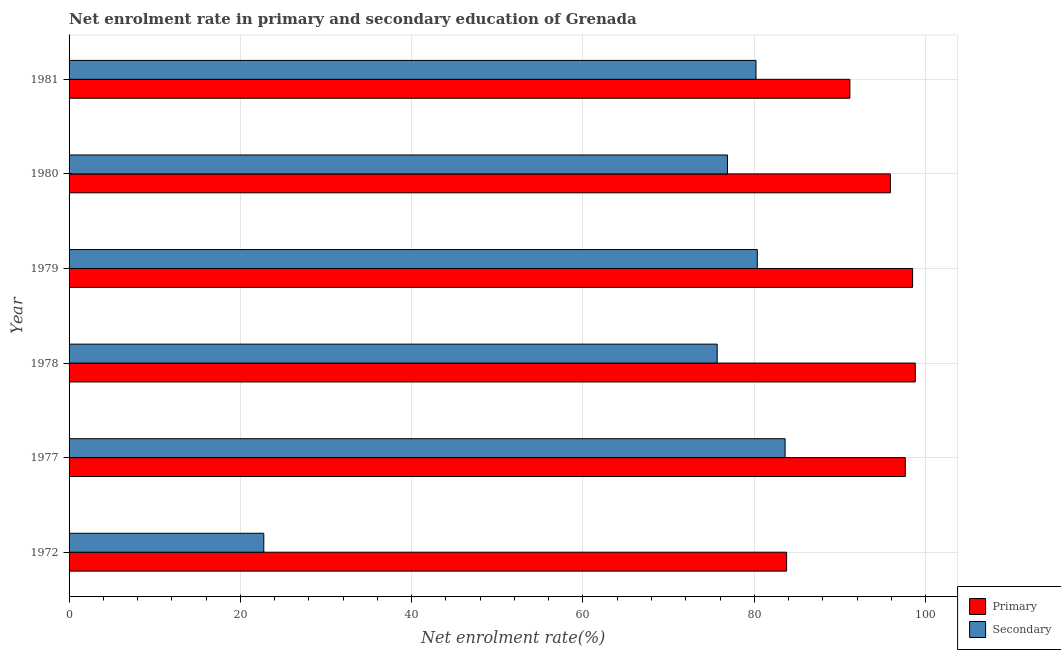How many different coloured bars are there?
Your answer should be compact. 2. Are the number of bars on each tick of the Y-axis equal?
Your answer should be compact. Yes. How many bars are there on the 2nd tick from the top?
Give a very brief answer. 2. What is the label of the 1st group of bars from the top?
Offer a terse response. 1981. What is the enrollment rate in primary education in 1981?
Offer a terse response. 91.16. Across all years, what is the maximum enrollment rate in primary education?
Keep it short and to the point. 98.8. Across all years, what is the minimum enrollment rate in primary education?
Your answer should be very brief. 83.77. In which year was the enrollment rate in primary education maximum?
Give a very brief answer. 1978. In which year was the enrollment rate in primary education minimum?
Your response must be concise. 1972. What is the total enrollment rate in primary education in the graph?
Make the answer very short. 565.73. What is the difference between the enrollment rate in primary education in 1978 and that in 1980?
Provide a succinct answer. 2.91. What is the difference between the enrollment rate in secondary education in 1981 and the enrollment rate in primary education in 1977?
Your answer should be compact. -17.43. What is the average enrollment rate in secondary education per year?
Ensure brevity in your answer.  69.9. In the year 1972, what is the difference between the enrollment rate in primary education and enrollment rate in secondary education?
Your answer should be compact. 61.04. What is the ratio of the enrollment rate in secondary education in 1977 to that in 1980?
Provide a short and direct response. 1.09. What is the difference between the highest and the second highest enrollment rate in secondary education?
Provide a succinct answer. 3.25. What is the difference between the highest and the lowest enrollment rate in secondary education?
Ensure brevity in your answer.  60.86. What does the 1st bar from the top in 1981 represents?
Give a very brief answer. Secondary. What does the 2nd bar from the bottom in 1979 represents?
Give a very brief answer. Secondary. How many bars are there?
Your answer should be compact. 12. What is the difference between two consecutive major ticks on the X-axis?
Your answer should be compact. 20. Are the values on the major ticks of X-axis written in scientific E-notation?
Give a very brief answer. No. How are the legend labels stacked?
Your answer should be compact. Vertical. What is the title of the graph?
Give a very brief answer. Net enrolment rate in primary and secondary education of Grenada. What is the label or title of the X-axis?
Make the answer very short. Net enrolment rate(%). What is the Net enrolment rate(%) of Primary in 1972?
Keep it short and to the point. 83.77. What is the Net enrolment rate(%) of Secondary in 1972?
Offer a terse response. 22.74. What is the Net enrolment rate(%) of Primary in 1977?
Provide a short and direct response. 97.63. What is the Net enrolment rate(%) of Secondary in 1977?
Provide a short and direct response. 83.6. What is the Net enrolment rate(%) of Primary in 1978?
Give a very brief answer. 98.8. What is the Net enrolment rate(%) in Secondary in 1978?
Provide a succinct answer. 75.67. What is the Net enrolment rate(%) in Primary in 1979?
Make the answer very short. 98.49. What is the Net enrolment rate(%) of Secondary in 1979?
Your answer should be very brief. 80.35. What is the Net enrolment rate(%) of Primary in 1980?
Offer a very short reply. 95.89. What is the Net enrolment rate(%) in Secondary in 1980?
Offer a very short reply. 76.87. What is the Net enrolment rate(%) of Primary in 1981?
Offer a very short reply. 91.16. What is the Net enrolment rate(%) in Secondary in 1981?
Ensure brevity in your answer.  80.2. Across all years, what is the maximum Net enrolment rate(%) in Primary?
Give a very brief answer. 98.8. Across all years, what is the maximum Net enrolment rate(%) of Secondary?
Offer a very short reply. 83.6. Across all years, what is the minimum Net enrolment rate(%) of Primary?
Offer a very short reply. 83.77. Across all years, what is the minimum Net enrolment rate(%) of Secondary?
Your answer should be very brief. 22.74. What is the total Net enrolment rate(%) in Primary in the graph?
Provide a short and direct response. 565.73. What is the total Net enrolment rate(%) of Secondary in the graph?
Offer a very short reply. 419.43. What is the difference between the Net enrolment rate(%) of Primary in 1972 and that in 1977?
Ensure brevity in your answer.  -13.86. What is the difference between the Net enrolment rate(%) in Secondary in 1972 and that in 1977?
Provide a short and direct response. -60.86. What is the difference between the Net enrolment rate(%) of Primary in 1972 and that in 1978?
Your response must be concise. -15.02. What is the difference between the Net enrolment rate(%) of Secondary in 1972 and that in 1978?
Provide a short and direct response. -52.93. What is the difference between the Net enrolment rate(%) in Primary in 1972 and that in 1979?
Make the answer very short. -14.71. What is the difference between the Net enrolment rate(%) in Secondary in 1972 and that in 1979?
Your answer should be very brief. -57.62. What is the difference between the Net enrolment rate(%) in Primary in 1972 and that in 1980?
Ensure brevity in your answer.  -12.11. What is the difference between the Net enrolment rate(%) of Secondary in 1972 and that in 1980?
Your answer should be compact. -54.14. What is the difference between the Net enrolment rate(%) in Primary in 1972 and that in 1981?
Your answer should be very brief. -7.39. What is the difference between the Net enrolment rate(%) in Secondary in 1972 and that in 1981?
Keep it short and to the point. -57.46. What is the difference between the Net enrolment rate(%) in Primary in 1977 and that in 1978?
Ensure brevity in your answer.  -1.17. What is the difference between the Net enrolment rate(%) of Secondary in 1977 and that in 1978?
Keep it short and to the point. 7.93. What is the difference between the Net enrolment rate(%) in Primary in 1977 and that in 1979?
Your response must be concise. -0.86. What is the difference between the Net enrolment rate(%) of Secondary in 1977 and that in 1979?
Your answer should be compact. 3.25. What is the difference between the Net enrolment rate(%) of Primary in 1977 and that in 1980?
Your response must be concise. 1.74. What is the difference between the Net enrolment rate(%) in Secondary in 1977 and that in 1980?
Give a very brief answer. 6.73. What is the difference between the Net enrolment rate(%) of Primary in 1977 and that in 1981?
Offer a terse response. 6.47. What is the difference between the Net enrolment rate(%) in Secondary in 1977 and that in 1981?
Ensure brevity in your answer.  3.4. What is the difference between the Net enrolment rate(%) of Primary in 1978 and that in 1979?
Offer a very short reply. 0.31. What is the difference between the Net enrolment rate(%) in Secondary in 1978 and that in 1979?
Give a very brief answer. -4.68. What is the difference between the Net enrolment rate(%) of Primary in 1978 and that in 1980?
Make the answer very short. 2.91. What is the difference between the Net enrolment rate(%) of Secondary in 1978 and that in 1980?
Keep it short and to the point. -1.2. What is the difference between the Net enrolment rate(%) in Primary in 1978 and that in 1981?
Ensure brevity in your answer.  7.64. What is the difference between the Net enrolment rate(%) of Secondary in 1978 and that in 1981?
Give a very brief answer. -4.53. What is the difference between the Net enrolment rate(%) of Primary in 1979 and that in 1980?
Keep it short and to the point. 2.6. What is the difference between the Net enrolment rate(%) in Secondary in 1979 and that in 1980?
Offer a terse response. 3.48. What is the difference between the Net enrolment rate(%) in Primary in 1979 and that in 1981?
Ensure brevity in your answer.  7.33. What is the difference between the Net enrolment rate(%) in Secondary in 1979 and that in 1981?
Your answer should be compact. 0.15. What is the difference between the Net enrolment rate(%) in Primary in 1980 and that in 1981?
Offer a very short reply. 4.73. What is the difference between the Net enrolment rate(%) in Secondary in 1980 and that in 1981?
Make the answer very short. -3.33. What is the difference between the Net enrolment rate(%) in Primary in 1972 and the Net enrolment rate(%) in Secondary in 1977?
Keep it short and to the point. 0.18. What is the difference between the Net enrolment rate(%) of Primary in 1972 and the Net enrolment rate(%) of Secondary in 1978?
Keep it short and to the point. 8.1. What is the difference between the Net enrolment rate(%) of Primary in 1972 and the Net enrolment rate(%) of Secondary in 1979?
Keep it short and to the point. 3.42. What is the difference between the Net enrolment rate(%) of Primary in 1972 and the Net enrolment rate(%) of Secondary in 1980?
Ensure brevity in your answer.  6.9. What is the difference between the Net enrolment rate(%) in Primary in 1972 and the Net enrolment rate(%) in Secondary in 1981?
Offer a very short reply. 3.57. What is the difference between the Net enrolment rate(%) in Primary in 1977 and the Net enrolment rate(%) in Secondary in 1978?
Your answer should be very brief. 21.96. What is the difference between the Net enrolment rate(%) in Primary in 1977 and the Net enrolment rate(%) in Secondary in 1979?
Ensure brevity in your answer.  17.28. What is the difference between the Net enrolment rate(%) of Primary in 1977 and the Net enrolment rate(%) of Secondary in 1980?
Provide a succinct answer. 20.76. What is the difference between the Net enrolment rate(%) of Primary in 1977 and the Net enrolment rate(%) of Secondary in 1981?
Your response must be concise. 17.43. What is the difference between the Net enrolment rate(%) in Primary in 1978 and the Net enrolment rate(%) in Secondary in 1979?
Give a very brief answer. 18.45. What is the difference between the Net enrolment rate(%) of Primary in 1978 and the Net enrolment rate(%) of Secondary in 1980?
Your answer should be compact. 21.93. What is the difference between the Net enrolment rate(%) of Primary in 1978 and the Net enrolment rate(%) of Secondary in 1981?
Ensure brevity in your answer.  18.6. What is the difference between the Net enrolment rate(%) in Primary in 1979 and the Net enrolment rate(%) in Secondary in 1980?
Give a very brief answer. 21.62. What is the difference between the Net enrolment rate(%) in Primary in 1979 and the Net enrolment rate(%) in Secondary in 1981?
Your answer should be compact. 18.29. What is the difference between the Net enrolment rate(%) in Primary in 1980 and the Net enrolment rate(%) in Secondary in 1981?
Provide a short and direct response. 15.69. What is the average Net enrolment rate(%) of Primary per year?
Your answer should be very brief. 94.29. What is the average Net enrolment rate(%) in Secondary per year?
Provide a succinct answer. 69.9. In the year 1972, what is the difference between the Net enrolment rate(%) of Primary and Net enrolment rate(%) of Secondary?
Your response must be concise. 61.04. In the year 1977, what is the difference between the Net enrolment rate(%) in Primary and Net enrolment rate(%) in Secondary?
Your answer should be compact. 14.03. In the year 1978, what is the difference between the Net enrolment rate(%) of Primary and Net enrolment rate(%) of Secondary?
Offer a terse response. 23.13. In the year 1979, what is the difference between the Net enrolment rate(%) of Primary and Net enrolment rate(%) of Secondary?
Offer a very short reply. 18.13. In the year 1980, what is the difference between the Net enrolment rate(%) of Primary and Net enrolment rate(%) of Secondary?
Give a very brief answer. 19.02. In the year 1981, what is the difference between the Net enrolment rate(%) of Primary and Net enrolment rate(%) of Secondary?
Keep it short and to the point. 10.96. What is the ratio of the Net enrolment rate(%) of Primary in 1972 to that in 1977?
Keep it short and to the point. 0.86. What is the ratio of the Net enrolment rate(%) of Secondary in 1972 to that in 1977?
Offer a terse response. 0.27. What is the ratio of the Net enrolment rate(%) in Primary in 1972 to that in 1978?
Make the answer very short. 0.85. What is the ratio of the Net enrolment rate(%) of Secondary in 1972 to that in 1978?
Make the answer very short. 0.3. What is the ratio of the Net enrolment rate(%) in Primary in 1972 to that in 1979?
Provide a succinct answer. 0.85. What is the ratio of the Net enrolment rate(%) in Secondary in 1972 to that in 1979?
Keep it short and to the point. 0.28. What is the ratio of the Net enrolment rate(%) in Primary in 1972 to that in 1980?
Give a very brief answer. 0.87. What is the ratio of the Net enrolment rate(%) in Secondary in 1972 to that in 1980?
Offer a terse response. 0.3. What is the ratio of the Net enrolment rate(%) of Primary in 1972 to that in 1981?
Offer a terse response. 0.92. What is the ratio of the Net enrolment rate(%) in Secondary in 1972 to that in 1981?
Keep it short and to the point. 0.28. What is the ratio of the Net enrolment rate(%) in Secondary in 1977 to that in 1978?
Your response must be concise. 1.1. What is the ratio of the Net enrolment rate(%) in Secondary in 1977 to that in 1979?
Your answer should be compact. 1.04. What is the ratio of the Net enrolment rate(%) of Primary in 1977 to that in 1980?
Offer a terse response. 1.02. What is the ratio of the Net enrolment rate(%) of Secondary in 1977 to that in 1980?
Provide a succinct answer. 1.09. What is the ratio of the Net enrolment rate(%) in Primary in 1977 to that in 1981?
Offer a very short reply. 1.07. What is the ratio of the Net enrolment rate(%) in Secondary in 1977 to that in 1981?
Give a very brief answer. 1.04. What is the ratio of the Net enrolment rate(%) of Primary in 1978 to that in 1979?
Your answer should be compact. 1. What is the ratio of the Net enrolment rate(%) in Secondary in 1978 to that in 1979?
Offer a terse response. 0.94. What is the ratio of the Net enrolment rate(%) in Primary in 1978 to that in 1980?
Provide a succinct answer. 1.03. What is the ratio of the Net enrolment rate(%) in Secondary in 1978 to that in 1980?
Offer a very short reply. 0.98. What is the ratio of the Net enrolment rate(%) in Primary in 1978 to that in 1981?
Make the answer very short. 1.08. What is the ratio of the Net enrolment rate(%) of Secondary in 1978 to that in 1981?
Offer a terse response. 0.94. What is the ratio of the Net enrolment rate(%) of Primary in 1979 to that in 1980?
Your response must be concise. 1.03. What is the ratio of the Net enrolment rate(%) of Secondary in 1979 to that in 1980?
Provide a short and direct response. 1.05. What is the ratio of the Net enrolment rate(%) of Primary in 1979 to that in 1981?
Make the answer very short. 1.08. What is the ratio of the Net enrolment rate(%) of Secondary in 1979 to that in 1981?
Provide a short and direct response. 1. What is the ratio of the Net enrolment rate(%) in Primary in 1980 to that in 1981?
Ensure brevity in your answer.  1.05. What is the ratio of the Net enrolment rate(%) of Secondary in 1980 to that in 1981?
Make the answer very short. 0.96. What is the difference between the highest and the second highest Net enrolment rate(%) in Primary?
Keep it short and to the point. 0.31. What is the difference between the highest and the second highest Net enrolment rate(%) of Secondary?
Offer a terse response. 3.25. What is the difference between the highest and the lowest Net enrolment rate(%) in Primary?
Provide a short and direct response. 15.02. What is the difference between the highest and the lowest Net enrolment rate(%) in Secondary?
Keep it short and to the point. 60.86. 